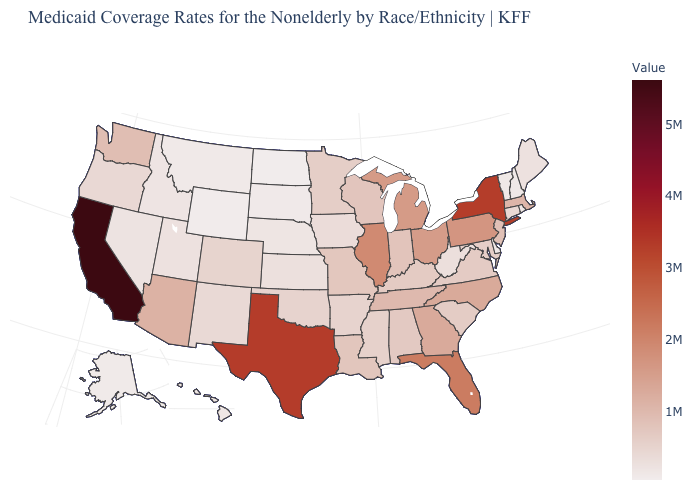Does Delaware have a lower value than Florida?
Be succinct. Yes. Among the states that border California , which have the highest value?
Short answer required. Arizona. Which states hav the highest value in the Northeast?
Short answer required. New York. Does New Hampshire have the highest value in the USA?
Short answer required. No. Does Missouri have a lower value than California?
Short answer required. Yes. 